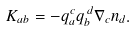Convert formula to latex. <formula><loc_0><loc_0><loc_500><loc_500>K _ { a b } = - q _ { a } ^ { \, c } q _ { b } ^ { \, d } \nabla _ { c } n _ { d } .</formula> 